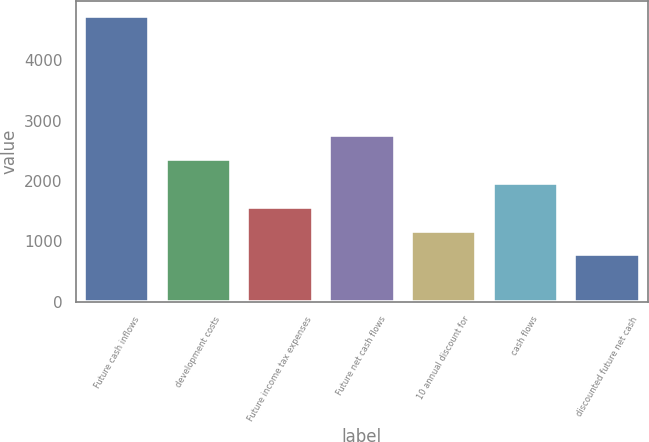Convert chart. <chart><loc_0><loc_0><loc_500><loc_500><bar_chart><fcel>Future cash inflows<fcel>development costs<fcel>Future income tax expenses<fcel>Future net cash flows<fcel>10 annual discount for<fcel>cash flows<fcel>discounted future net cash<nl><fcel>4743<fcel>2366.4<fcel>1574.2<fcel>2762.5<fcel>1178.1<fcel>1970.3<fcel>782<nl></chart> 